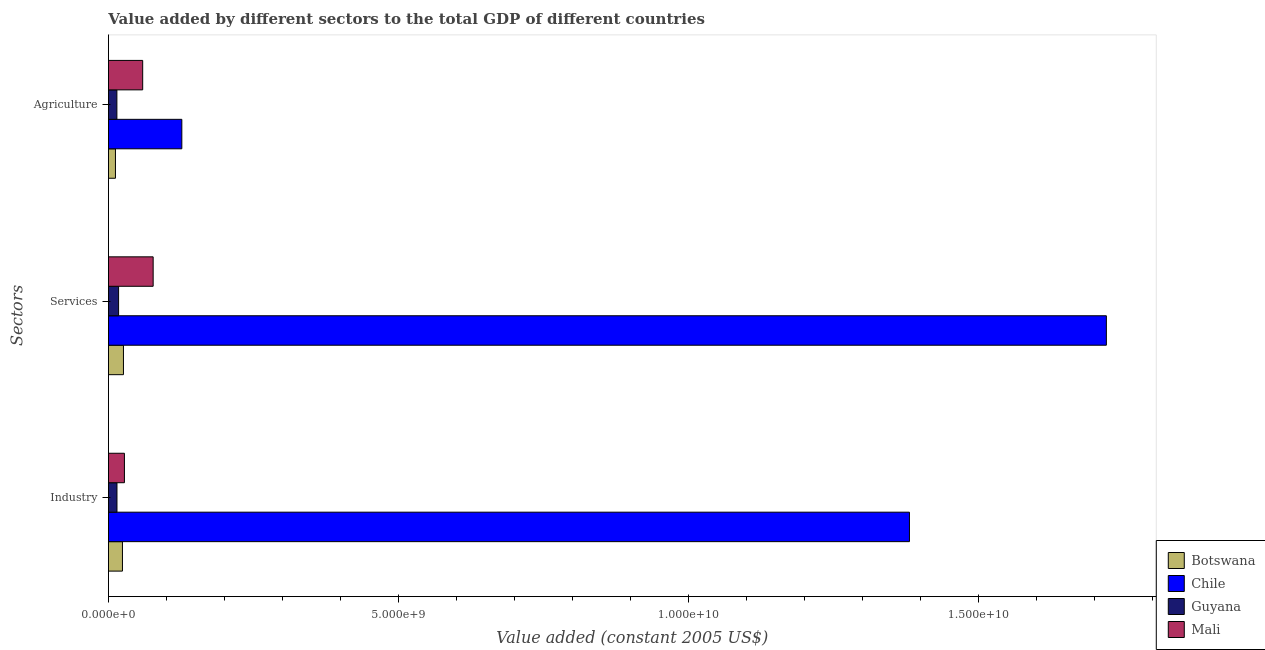How many different coloured bars are there?
Keep it short and to the point. 4. Are the number of bars per tick equal to the number of legend labels?
Give a very brief answer. Yes. Are the number of bars on each tick of the Y-axis equal?
Your answer should be very brief. Yes. How many bars are there on the 1st tick from the top?
Offer a terse response. 4. How many bars are there on the 3rd tick from the bottom?
Give a very brief answer. 4. What is the label of the 2nd group of bars from the top?
Provide a succinct answer. Services. What is the value added by agricultural sector in Guyana?
Your answer should be compact. 1.46e+08. Across all countries, what is the maximum value added by industrial sector?
Your answer should be compact. 1.38e+1. Across all countries, what is the minimum value added by industrial sector?
Keep it short and to the point. 1.47e+08. In which country was the value added by agricultural sector maximum?
Your answer should be very brief. Chile. In which country was the value added by agricultural sector minimum?
Offer a terse response. Botswana. What is the total value added by industrial sector in the graph?
Your answer should be compact. 1.45e+1. What is the difference between the value added by agricultural sector in Chile and that in Mali?
Give a very brief answer. 6.75e+08. What is the difference between the value added by services in Mali and the value added by agricultural sector in Chile?
Offer a very short reply. -4.94e+08. What is the average value added by agricultural sector per country?
Keep it short and to the point. 5.31e+08. What is the difference between the value added by industrial sector and value added by services in Mali?
Give a very brief answer. -4.95e+08. What is the ratio of the value added by agricultural sector in Botswana to that in Mali?
Your answer should be very brief. 0.21. What is the difference between the highest and the second highest value added by services?
Your answer should be compact. 1.64e+1. What is the difference between the highest and the lowest value added by industrial sector?
Your answer should be very brief. 1.37e+1. In how many countries, is the value added by agricultural sector greater than the average value added by agricultural sector taken over all countries?
Keep it short and to the point. 2. What does the 4th bar from the bottom in Agriculture represents?
Make the answer very short. Mali. Are all the bars in the graph horizontal?
Your response must be concise. Yes. What is the difference between two consecutive major ticks on the X-axis?
Your answer should be compact. 5.00e+09. Are the values on the major ticks of X-axis written in scientific E-notation?
Your response must be concise. Yes. Does the graph contain any zero values?
Your response must be concise. No. Does the graph contain grids?
Give a very brief answer. No. Where does the legend appear in the graph?
Provide a short and direct response. Bottom right. How many legend labels are there?
Your answer should be very brief. 4. What is the title of the graph?
Your response must be concise. Value added by different sectors to the total GDP of different countries. What is the label or title of the X-axis?
Make the answer very short. Value added (constant 2005 US$). What is the label or title of the Y-axis?
Your answer should be very brief. Sectors. What is the Value added (constant 2005 US$) of Botswana in Industry?
Keep it short and to the point. 2.42e+08. What is the Value added (constant 2005 US$) in Chile in Industry?
Offer a very short reply. 1.38e+1. What is the Value added (constant 2005 US$) in Guyana in Industry?
Make the answer very short. 1.47e+08. What is the Value added (constant 2005 US$) of Mali in Industry?
Offer a terse response. 2.76e+08. What is the Value added (constant 2005 US$) in Botswana in Services?
Keep it short and to the point. 2.59e+08. What is the Value added (constant 2005 US$) in Chile in Services?
Offer a terse response. 1.72e+1. What is the Value added (constant 2005 US$) in Guyana in Services?
Provide a succinct answer. 1.75e+08. What is the Value added (constant 2005 US$) of Mali in Services?
Make the answer very short. 7.71e+08. What is the Value added (constant 2005 US$) of Botswana in Agriculture?
Provide a succinct answer. 1.21e+08. What is the Value added (constant 2005 US$) in Chile in Agriculture?
Offer a very short reply. 1.26e+09. What is the Value added (constant 2005 US$) in Guyana in Agriculture?
Ensure brevity in your answer.  1.46e+08. What is the Value added (constant 2005 US$) in Mali in Agriculture?
Ensure brevity in your answer.  5.90e+08. Across all Sectors, what is the maximum Value added (constant 2005 US$) of Botswana?
Your response must be concise. 2.59e+08. Across all Sectors, what is the maximum Value added (constant 2005 US$) in Chile?
Keep it short and to the point. 1.72e+1. Across all Sectors, what is the maximum Value added (constant 2005 US$) in Guyana?
Ensure brevity in your answer.  1.75e+08. Across all Sectors, what is the maximum Value added (constant 2005 US$) in Mali?
Ensure brevity in your answer.  7.71e+08. Across all Sectors, what is the minimum Value added (constant 2005 US$) of Botswana?
Ensure brevity in your answer.  1.21e+08. Across all Sectors, what is the minimum Value added (constant 2005 US$) of Chile?
Provide a succinct answer. 1.26e+09. Across all Sectors, what is the minimum Value added (constant 2005 US$) in Guyana?
Offer a very short reply. 1.46e+08. Across all Sectors, what is the minimum Value added (constant 2005 US$) in Mali?
Offer a terse response. 2.76e+08. What is the total Value added (constant 2005 US$) of Botswana in the graph?
Your answer should be very brief. 6.21e+08. What is the total Value added (constant 2005 US$) of Chile in the graph?
Keep it short and to the point. 3.23e+1. What is the total Value added (constant 2005 US$) in Guyana in the graph?
Provide a succinct answer. 4.68e+08. What is the total Value added (constant 2005 US$) of Mali in the graph?
Keep it short and to the point. 1.64e+09. What is the difference between the Value added (constant 2005 US$) of Botswana in Industry and that in Services?
Make the answer very short. -1.72e+07. What is the difference between the Value added (constant 2005 US$) in Chile in Industry and that in Services?
Offer a terse response. -3.39e+09. What is the difference between the Value added (constant 2005 US$) in Guyana in Industry and that in Services?
Provide a short and direct response. -2.78e+07. What is the difference between the Value added (constant 2005 US$) in Mali in Industry and that in Services?
Keep it short and to the point. -4.95e+08. What is the difference between the Value added (constant 2005 US$) of Botswana in Industry and that in Agriculture?
Keep it short and to the point. 1.20e+08. What is the difference between the Value added (constant 2005 US$) in Chile in Industry and that in Agriculture?
Your answer should be compact. 1.25e+1. What is the difference between the Value added (constant 2005 US$) in Guyana in Industry and that in Agriculture?
Keep it short and to the point. 1.37e+06. What is the difference between the Value added (constant 2005 US$) of Mali in Industry and that in Agriculture?
Offer a terse response. -3.15e+08. What is the difference between the Value added (constant 2005 US$) of Botswana in Services and that in Agriculture?
Your response must be concise. 1.38e+08. What is the difference between the Value added (constant 2005 US$) in Chile in Services and that in Agriculture?
Give a very brief answer. 1.59e+1. What is the difference between the Value added (constant 2005 US$) in Guyana in Services and that in Agriculture?
Your answer should be very brief. 2.92e+07. What is the difference between the Value added (constant 2005 US$) of Mali in Services and that in Agriculture?
Keep it short and to the point. 1.80e+08. What is the difference between the Value added (constant 2005 US$) of Botswana in Industry and the Value added (constant 2005 US$) of Chile in Services?
Offer a terse response. -1.70e+1. What is the difference between the Value added (constant 2005 US$) in Botswana in Industry and the Value added (constant 2005 US$) in Guyana in Services?
Keep it short and to the point. 6.65e+07. What is the difference between the Value added (constant 2005 US$) in Botswana in Industry and the Value added (constant 2005 US$) in Mali in Services?
Your answer should be very brief. -5.29e+08. What is the difference between the Value added (constant 2005 US$) of Chile in Industry and the Value added (constant 2005 US$) of Guyana in Services?
Your response must be concise. 1.36e+1. What is the difference between the Value added (constant 2005 US$) of Chile in Industry and the Value added (constant 2005 US$) of Mali in Services?
Offer a very short reply. 1.30e+1. What is the difference between the Value added (constant 2005 US$) in Guyana in Industry and the Value added (constant 2005 US$) in Mali in Services?
Provide a succinct answer. -6.24e+08. What is the difference between the Value added (constant 2005 US$) of Botswana in Industry and the Value added (constant 2005 US$) of Chile in Agriculture?
Your response must be concise. -1.02e+09. What is the difference between the Value added (constant 2005 US$) in Botswana in Industry and the Value added (constant 2005 US$) in Guyana in Agriculture?
Your response must be concise. 9.57e+07. What is the difference between the Value added (constant 2005 US$) of Botswana in Industry and the Value added (constant 2005 US$) of Mali in Agriculture?
Keep it short and to the point. -3.49e+08. What is the difference between the Value added (constant 2005 US$) of Chile in Industry and the Value added (constant 2005 US$) of Guyana in Agriculture?
Your response must be concise. 1.37e+1. What is the difference between the Value added (constant 2005 US$) of Chile in Industry and the Value added (constant 2005 US$) of Mali in Agriculture?
Your answer should be compact. 1.32e+1. What is the difference between the Value added (constant 2005 US$) of Guyana in Industry and the Value added (constant 2005 US$) of Mali in Agriculture?
Your response must be concise. -4.43e+08. What is the difference between the Value added (constant 2005 US$) of Botswana in Services and the Value added (constant 2005 US$) of Chile in Agriculture?
Offer a very short reply. -1.01e+09. What is the difference between the Value added (constant 2005 US$) in Botswana in Services and the Value added (constant 2005 US$) in Guyana in Agriculture?
Your response must be concise. 1.13e+08. What is the difference between the Value added (constant 2005 US$) in Botswana in Services and the Value added (constant 2005 US$) in Mali in Agriculture?
Provide a short and direct response. -3.32e+08. What is the difference between the Value added (constant 2005 US$) in Chile in Services and the Value added (constant 2005 US$) in Guyana in Agriculture?
Ensure brevity in your answer.  1.71e+1. What is the difference between the Value added (constant 2005 US$) in Chile in Services and the Value added (constant 2005 US$) in Mali in Agriculture?
Ensure brevity in your answer.  1.66e+1. What is the difference between the Value added (constant 2005 US$) in Guyana in Services and the Value added (constant 2005 US$) in Mali in Agriculture?
Provide a short and direct response. -4.15e+08. What is the average Value added (constant 2005 US$) of Botswana per Sectors?
Offer a very short reply. 2.07e+08. What is the average Value added (constant 2005 US$) of Chile per Sectors?
Ensure brevity in your answer.  1.08e+1. What is the average Value added (constant 2005 US$) in Guyana per Sectors?
Offer a terse response. 1.56e+08. What is the average Value added (constant 2005 US$) in Mali per Sectors?
Keep it short and to the point. 5.46e+08. What is the difference between the Value added (constant 2005 US$) in Botswana and Value added (constant 2005 US$) in Chile in Industry?
Make the answer very short. -1.36e+1. What is the difference between the Value added (constant 2005 US$) of Botswana and Value added (constant 2005 US$) of Guyana in Industry?
Keep it short and to the point. 9.43e+07. What is the difference between the Value added (constant 2005 US$) of Botswana and Value added (constant 2005 US$) of Mali in Industry?
Keep it short and to the point. -3.41e+07. What is the difference between the Value added (constant 2005 US$) of Chile and Value added (constant 2005 US$) of Guyana in Industry?
Offer a terse response. 1.37e+1. What is the difference between the Value added (constant 2005 US$) in Chile and Value added (constant 2005 US$) in Mali in Industry?
Keep it short and to the point. 1.35e+1. What is the difference between the Value added (constant 2005 US$) of Guyana and Value added (constant 2005 US$) of Mali in Industry?
Give a very brief answer. -1.28e+08. What is the difference between the Value added (constant 2005 US$) in Botswana and Value added (constant 2005 US$) in Chile in Services?
Give a very brief answer. -1.69e+1. What is the difference between the Value added (constant 2005 US$) in Botswana and Value added (constant 2005 US$) in Guyana in Services?
Make the answer very short. 8.38e+07. What is the difference between the Value added (constant 2005 US$) in Botswana and Value added (constant 2005 US$) in Mali in Services?
Provide a short and direct response. -5.12e+08. What is the difference between the Value added (constant 2005 US$) of Chile and Value added (constant 2005 US$) of Guyana in Services?
Your response must be concise. 1.70e+1. What is the difference between the Value added (constant 2005 US$) of Chile and Value added (constant 2005 US$) of Mali in Services?
Your answer should be very brief. 1.64e+1. What is the difference between the Value added (constant 2005 US$) in Guyana and Value added (constant 2005 US$) in Mali in Services?
Make the answer very short. -5.96e+08. What is the difference between the Value added (constant 2005 US$) of Botswana and Value added (constant 2005 US$) of Chile in Agriculture?
Give a very brief answer. -1.14e+09. What is the difference between the Value added (constant 2005 US$) of Botswana and Value added (constant 2005 US$) of Guyana in Agriculture?
Ensure brevity in your answer.  -2.48e+07. What is the difference between the Value added (constant 2005 US$) of Botswana and Value added (constant 2005 US$) of Mali in Agriculture?
Offer a terse response. -4.69e+08. What is the difference between the Value added (constant 2005 US$) of Chile and Value added (constant 2005 US$) of Guyana in Agriculture?
Give a very brief answer. 1.12e+09. What is the difference between the Value added (constant 2005 US$) in Chile and Value added (constant 2005 US$) in Mali in Agriculture?
Provide a succinct answer. 6.75e+08. What is the difference between the Value added (constant 2005 US$) in Guyana and Value added (constant 2005 US$) in Mali in Agriculture?
Your answer should be compact. -4.44e+08. What is the ratio of the Value added (constant 2005 US$) in Botswana in Industry to that in Services?
Keep it short and to the point. 0.93. What is the ratio of the Value added (constant 2005 US$) in Chile in Industry to that in Services?
Provide a succinct answer. 0.8. What is the ratio of the Value added (constant 2005 US$) of Guyana in Industry to that in Services?
Make the answer very short. 0.84. What is the ratio of the Value added (constant 2005 US$) of Mali in Industry to that in Services?
Make the answer very short. 0.36. What is the ratio of the Value added (constant 2005 US$) of Botswana in Industry to that in Agriculture?
Your answer should be very brief. 1.99. What is the ratio of the Value added (constant 2005 US$) in Chile in Industry to that in Agriculture?
Keep it short and to the point. 10.91. What is the ratio of the Value added (constant 2005 US$) in Guyana in Industry to that in Agriculture?
Your answer should be compact. 1.01. What is the ratio of the Value added (constant 2005 US$) in Mali in Industry to that in Agriculture?
Provide a short and direct response. 0.47. What is the ratio of the Value added (constant 2005 US$) in Botswana in Services to that in Agriculture?
Ensure brevity in your answer.  2.14. What is the ratio of the Value added (constant 2005 US$) in Chile in Services to that in Agriculture?
Offer a terse response. 13.6. What is the ratio of the Value added (constant 2005 US$) of Guyana in Services to that in Agriculture?
Ensure brevity in your answer.  1.2. What is the ratio of the Value added (constant 2005 US$) in Mali in Services to that in Agriculture?
Your response must be concise. 1.31. What is the difference between the highest and the second highest Value added (constant 2005 US$) in Botswana?
Your response must be concise. 1.72e+07. What is the difference between the highest and the second highest Value added (constant 2005 US$) of Chile?
Your response must be concise. 3.39e+09. What is the difference between the highest and the second highest Value added (constant 2005 US$) in Guyana?
Provide a succinct answer. 2.78e+07. What is the difference between the highest and the second highest Value added (constant 2005 US$) of Mali?
Keep it short and to the point. 1.80e+08. What is the difference between the highest and the lowest Value added (constant 2005 US$) in Botswana?
Your response must be concise. 1.38e+08. What is the difference between the highest and the lowest Value added (constant 2005 US$) of Chile?
Your response must be concise. 1.59e+1. What is the difference between the highest and the lowest Value added (constant 2005 US$) of Guyana?
Ensure brevity in your answer.  2.92e+07. What is the difference between the highest and the lowest Value added (constant 2005 US$) of Mali?
Offer a very short reply. 4.95e+08. 